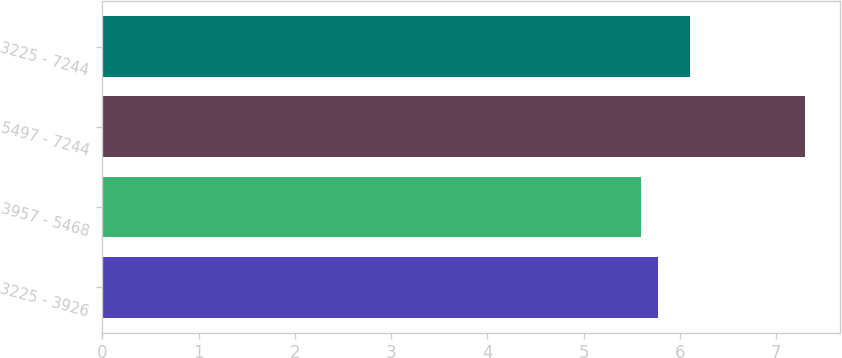<chart> <loc_0><loc_0><loc_500><loc_500><bar_chart><fcel>3225 - 3926<fcel>3957 - 5468<fcel>5497 - 7244<fcel>3225 - 7244<nl><fcel>5.77<fcel>5.6<fcel>7.3<fcel>6.1<nl></chart> 